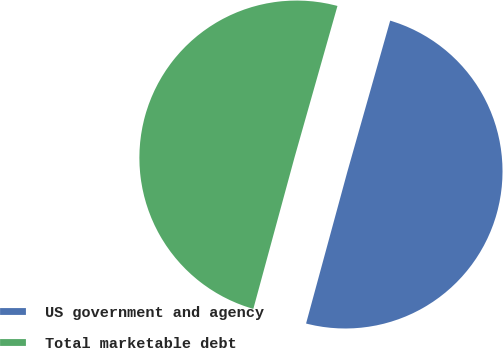Convert chart to OTSL. <chart><loc_0><loc_0><loc_500><loc_500><pie_chart><fcel>US government and agency<fcel>Total marketable debt<nl><fcel>49.83%<fcel>50.17%<nl></chart> 